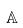Convert formula to latex. <formula><loc_0><loc_0><loc_500><loc_500>\mathbb { A }</formula> 